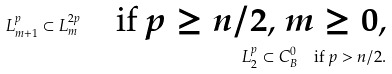Convert formula to latex. <formula><loc_0><loc_0><loc_500><loc_500>L ^ { p } _ { m + 1 } \subset L ^ { 2 p } _ { m } \quad \text {if $p\geq n/2$, $m\geq0$,} \\ L ^ { p } _ { 2 } \subset C ^ { 0 } _ { B } \quad \text {if $p>n/2$.}</formula> 